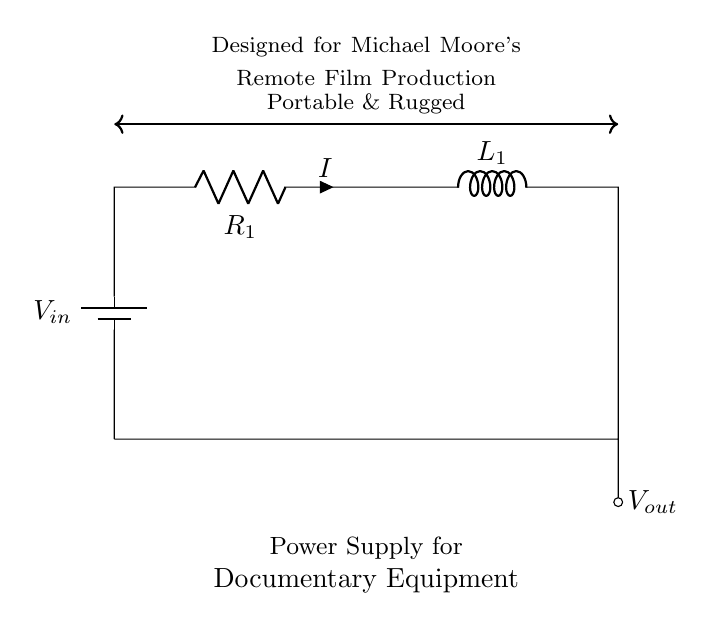What is the input voltage of the circuit? The input voltage is represented by V_in, which is typically the supply voltage for the circuit.
Answer: V_in What type of components are used in this circuit? The components used are a battery, a resistor, and an inductor. The battery supplies power while the resistor and inductor are used for current control.
Answer: Battery, resistor, inductor What is the current flowing through the circuit denoted as? The current flowing through the circuit is denoted by the letter I, which is labeled next to the resistor in the circuit diagram.
Answer: I How are the resistor and inductor connected in this circuit? The resistor and inductor are connected in series. This means that current must flow through the resistor before it reaches the inductor.
Answer: Series What is the purpose of using a resistor and inductor in this circuit? The purpose of the resistor and inductor is to manage and control the flow of current. The resistor provides resistance, while the inductor stores energy in its magnetic field.
Answer: Current control What is the significance of the label "Portable & Rugged"? The label indicates that the design of the circuit is intended for use in locations where durability and portability are crucial, often found in remote film production contexts.
Answer: Durability and portability 